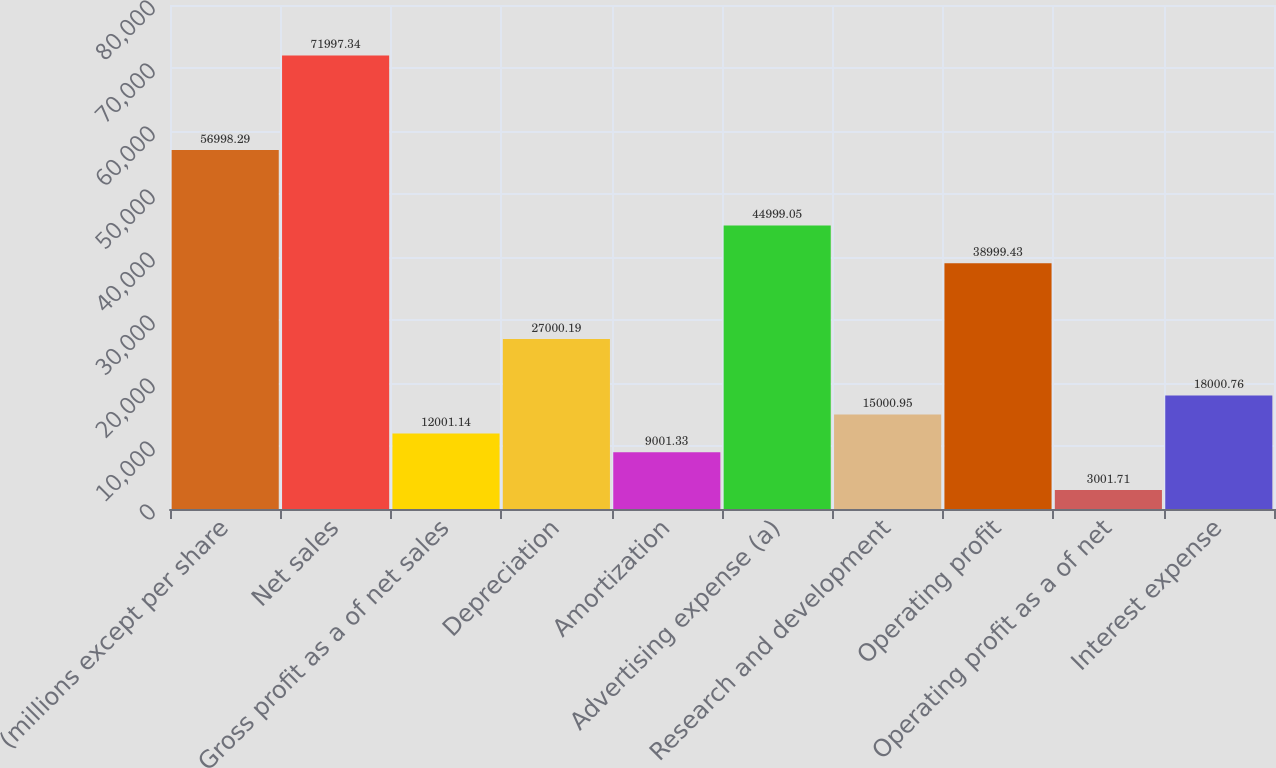Convert chart to OTSL. <chart><loc_0><loc_0><loc_500><loc_500><bar_chart><fcel>(millions except per share<fcel>Net sales<fcel>Gross profit as a of net sales<fcel>Depreciation<fcel>Amortization<fcel>Advertising expense (a)<fcel>Research and development<fcel>Operating profit<fcel>Operating profit as a of net<fcel>Interest expense<nl><fcel>56998.3<fcel>71997.3<fcel>12001.1<fcel>27000.2<fcel>9001.33<fcel>44999.1<fcel>15001<fcel>38999.4<fcel>3001.71<fcel>18000.8<nl></chart> 